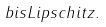Convert formula to latex. <formula><loc_0><loc_0><loc_500><loc_500>b i s L i p s c h i t z .</formula> 